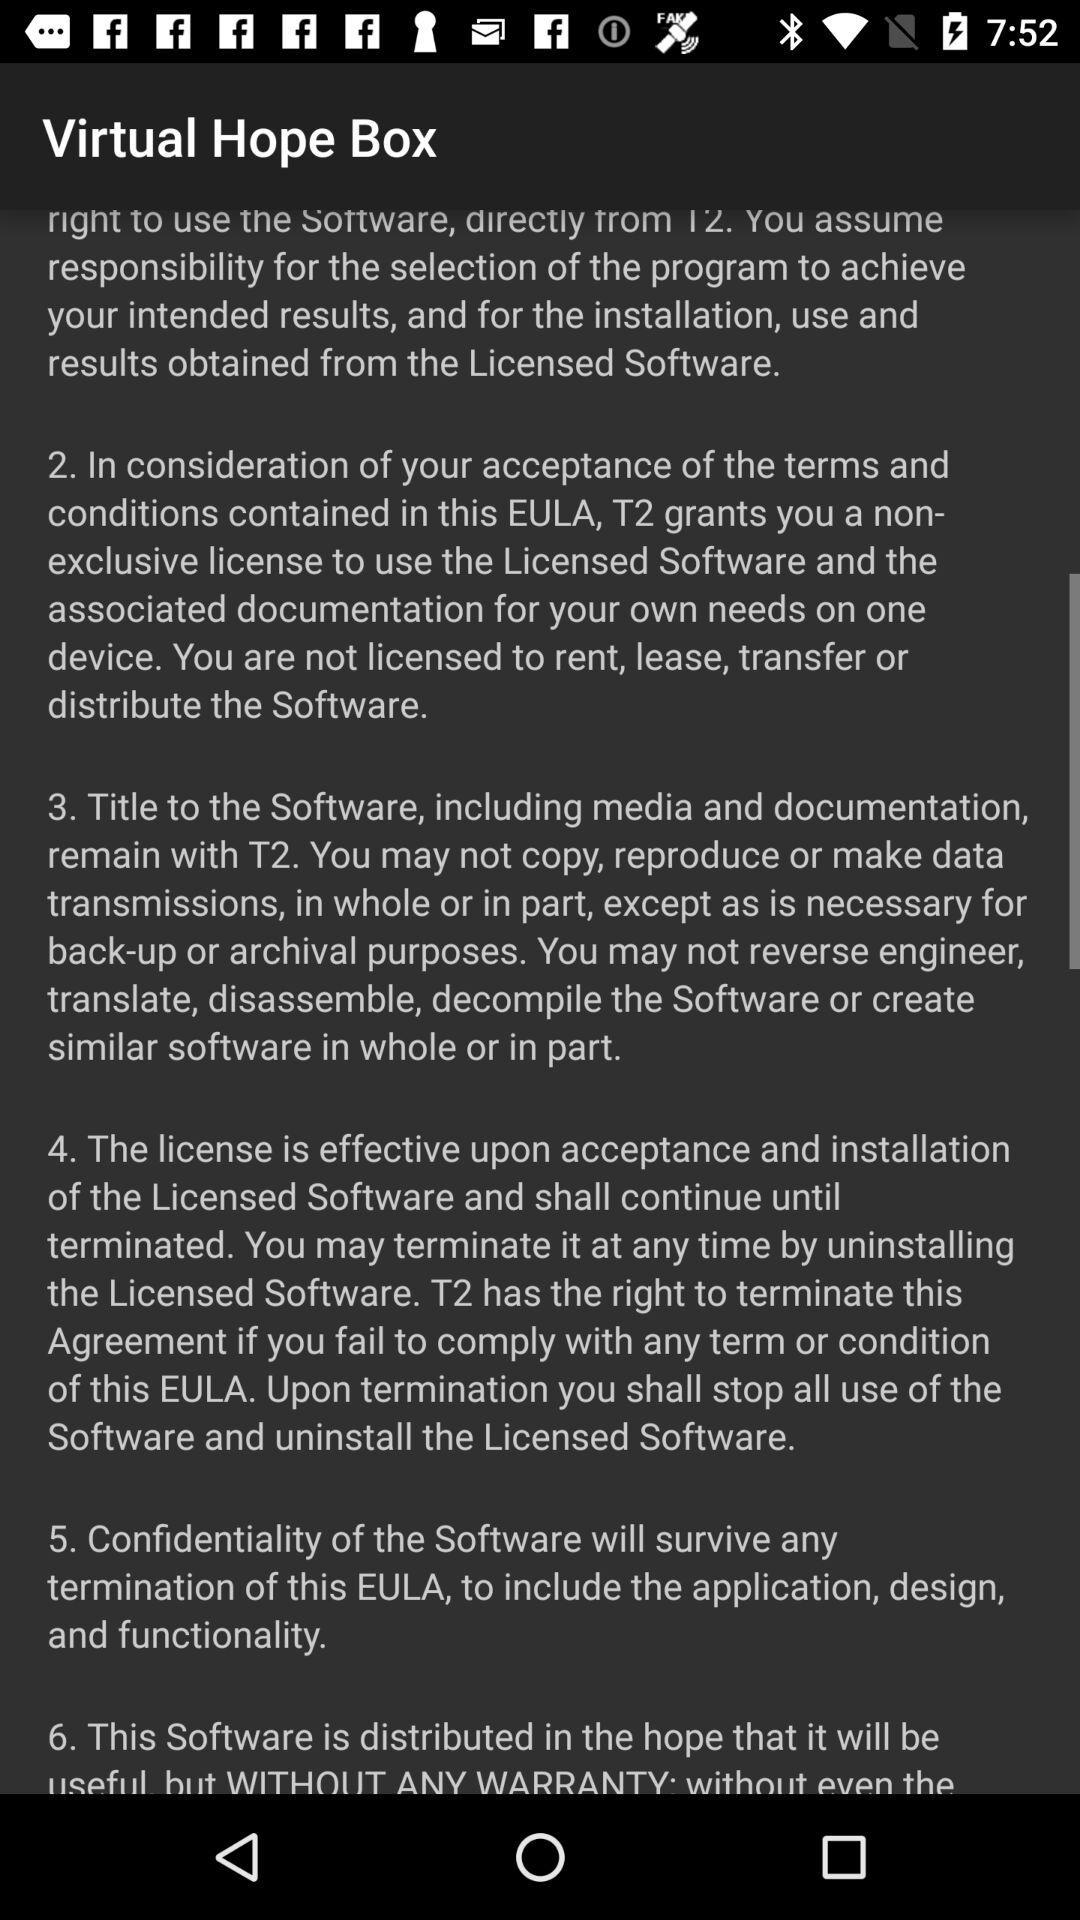What is the application name? The application name is "Virtual Hope Box". 